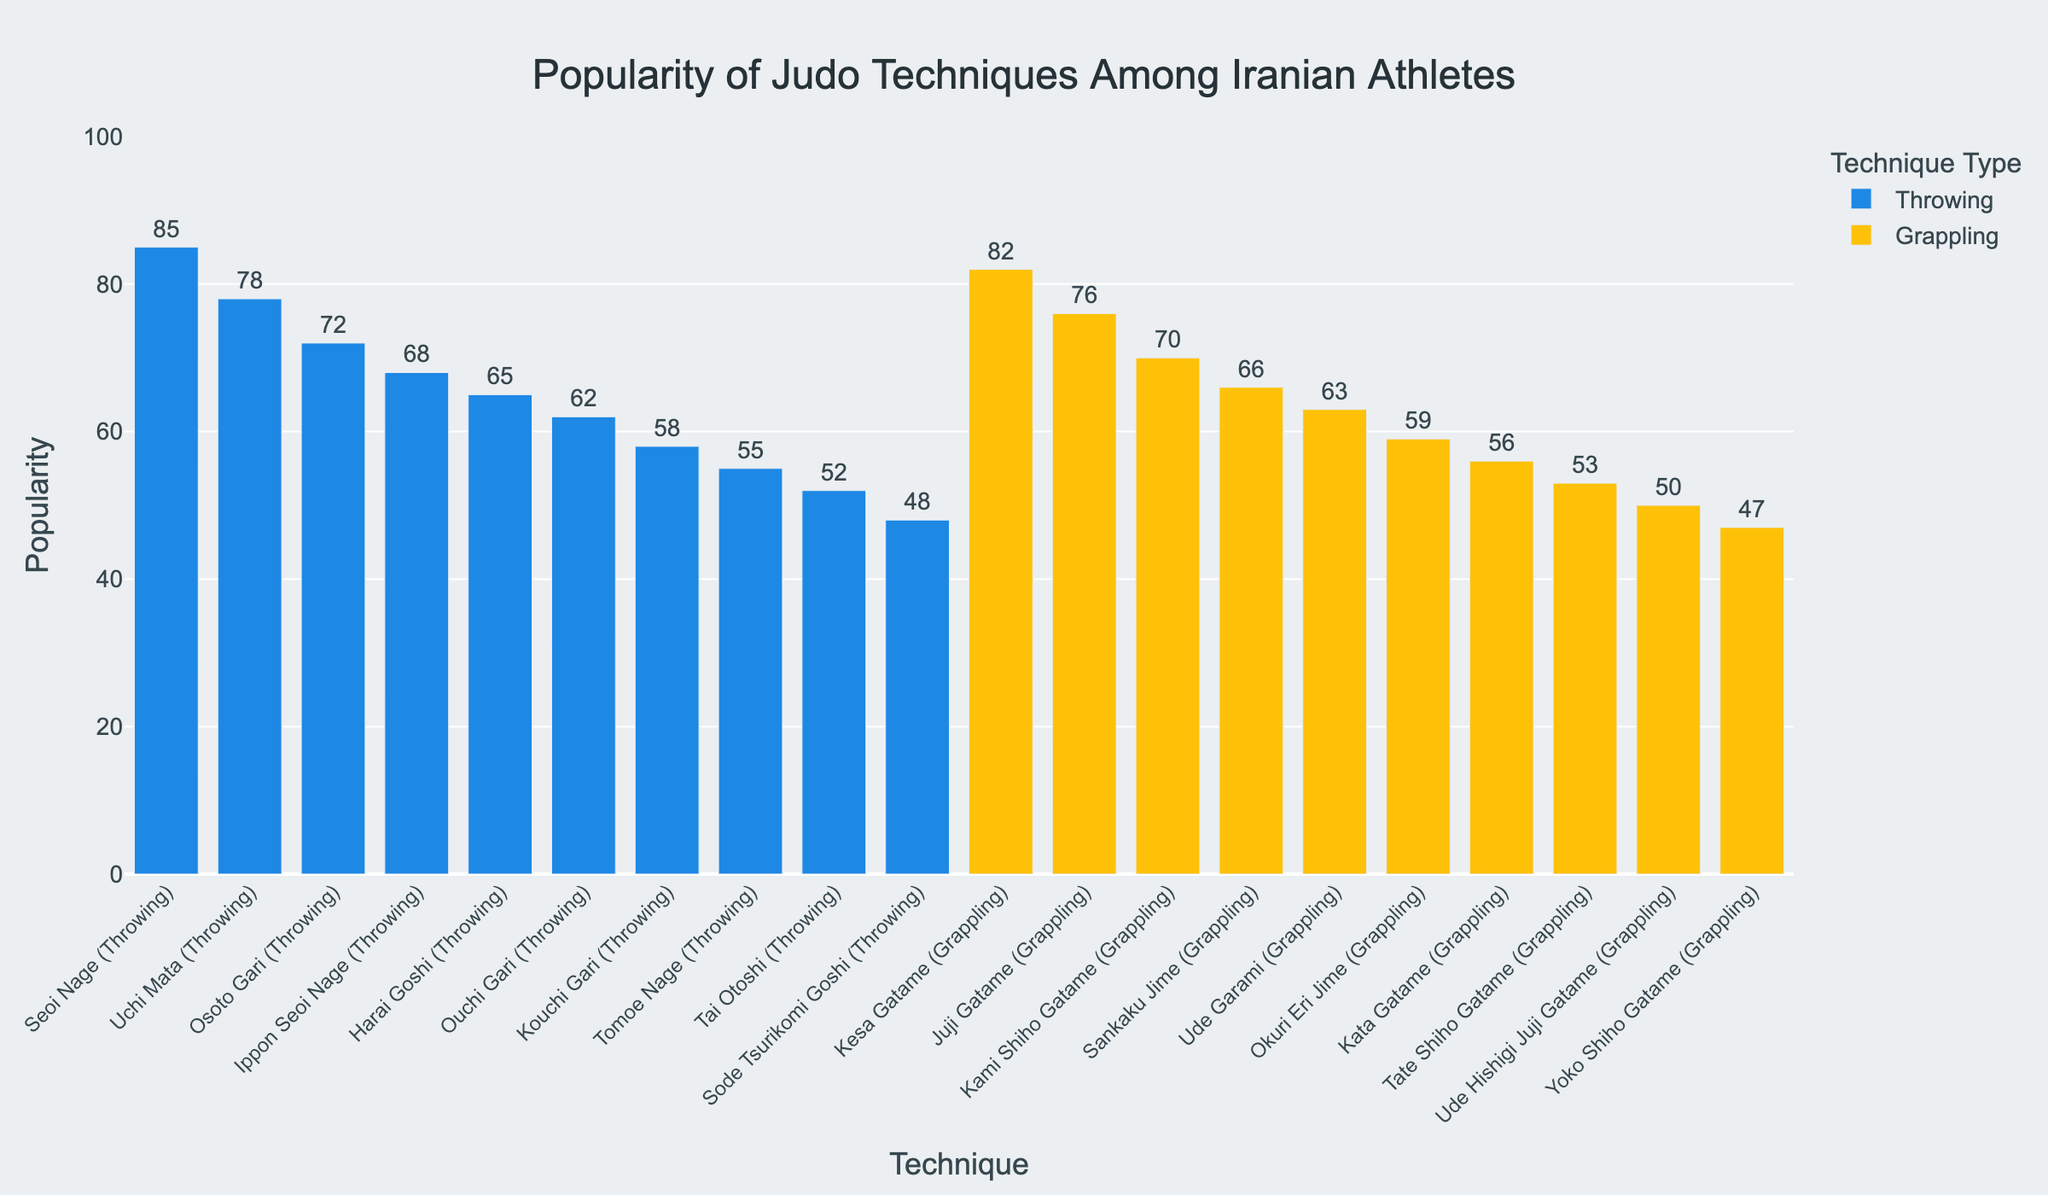What are the two most popular judo techniques among Iranian athletes? The two tallest bars in the chart represent the most popular techniques. "Seoi Nage" (Throwing) and "Kesa Gatame" (Grappling) have the highest popularity values of 85 and 82, respectively.
Answer: Seoi Nage, Kesa Gatame Which has more popularity, "Osoto Gari" or "Kami Shiho Gatame"? "Osoto Gari" has a popularity value of 72, while "Kami Shiho Gatame" has a popularity value of 70. 72 is greater than 70 so "Osoto Gari" is more popular.
Answer: Osoto Gari What is the total popularity of all throwing techniques combined? Adding up the popularity of all the throwing techniques: 85 + 78 + 72 + 68 + 65 + 62 + 58 + 55 + 52 + 48 = 643
Answer: 643 Which grappling move has the least popularity, and what is its value? The shortest bar among grappling moves represents the least popular technique. "Yoko Shiho Gatame" has the least popularity value, which is 47.
Answer: Yoko Shiho Gatame, 47 What is the average popularity of grappling techniques? Adding up the popularity values of all grappling techniques 82 + 76 + 70 + 66 + 63 + 59 + 56 + 53 + 50 + 47 = 622. There are 10 grappling techniques, so the average is 622 / 10 = 62.2
Answer: 62.2 Which technique type, throwing or grappling, is overall more popular? Summing the popularity values: Throwing techniques total 643 and Grappling techniques total 622. 643 is greater than 622, so throwing techniques are overall more popular.
Answer: Throwing What is the difference in popularity between the most popular throwing technique and the least popular grappling technique? The most popular throwing technique is "Seoi Nage" with 85, and the least popular grappling technique is "Yoko Shiho Gatame" with 47. So the difference is 85 - 47 = 38.
Answer: 38 How many techniques (both throwing and grappling) have a popularity value greater than 60? Counting the number of techniques with popularity values greater than 60: Seoi Nage (85), Uchi Mata (78), Osoto Gari (72), Ippon Seoi Nage (68), Harai Goshi (65), Kesa Gatame (82), Juji Gatame (76), Kami Shiho Gatame (70), Sankaku Jime (66), Ude Garami (63). Total = 10 techniques.
Answer: 10 Which is more, the total popularity of the three most popular techniques or the combined popularity of the three least popular techniques? Adding the three most popular techniques: Seoi Nage (85), Kesa Gatame (82), Uchi Mata (78) = 85 + 82 + 78 = 245. Adding the three least popular techniques: Sode Tsurikomi Goshi (48), Ude Hishigi Juji Gatame (50), Yoko Shiho Gatame (47) = 48 + 50 + 47 = 145. 245 is greater than 145.
Answer: The three most popular techniques 